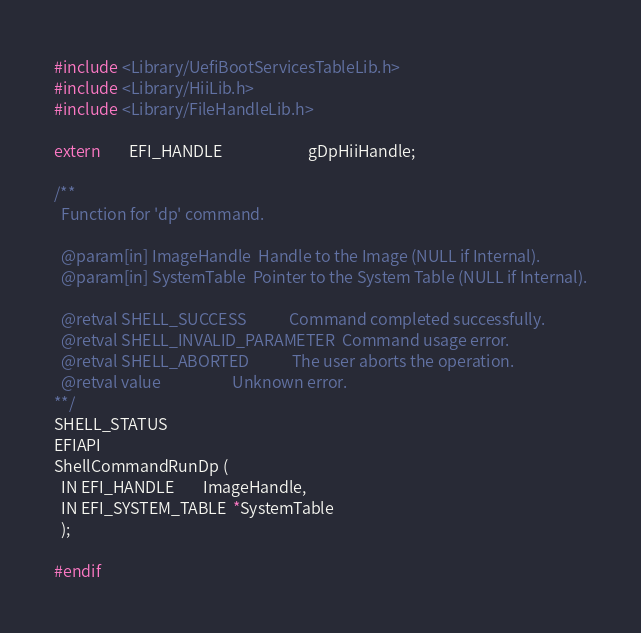Convert code to text. <code><loc_0><loc_0><loc_500><loc_500><_C_>#include <Library/UefiBootServicesTableLib.h>
#include <Library/HiiLib.h>
#include <Library/FileHandleLib.h>

extern        EFI_HANDLE                        gDpHiiHandle;

/**
  Function for 'dp' command.

  @param[in] ImageHandle  Handle to the Image (NULL if Internal).
  @param[in] SystemTable  Pointer to the System Table (NULL if Internal).

  @retval SHELL_SUCCESS            Command completed successfully.
  @retval SHELL_INVALID_PARAMETER  Command usage error.
  @retval SHELL_ABORTED            The user aborts the operation.
  @retval value                    Unknown error.
**/
SHELL_STATUS
EFIAPI
ShellCommandRunDp (
  IN EFI_HANDLE        ImageHandle,
  IN EFI_SYSTEM_TABLE  *SystemTable
  );

#endif

</code> 